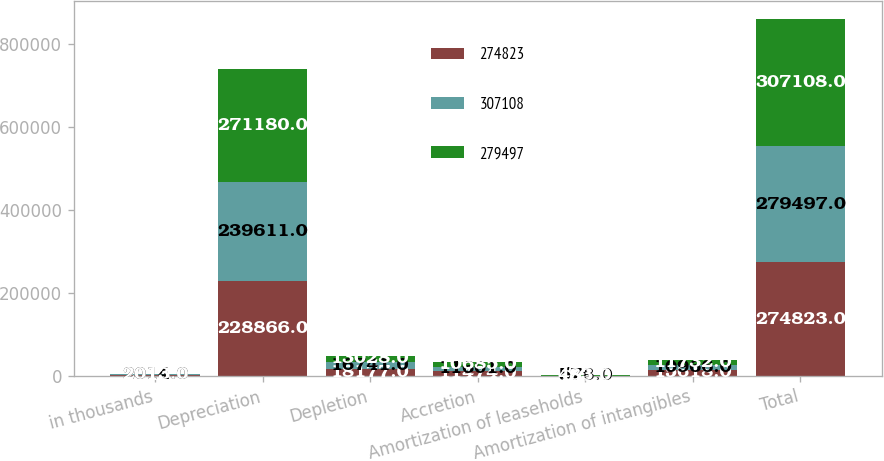Convert chart to OTSL. <chart><loc_0><loc_0><loc_500><loc_500><stacked_bar_chart><ecel><fcel>in thousands<fcel>Depreciation<fcel>Depletion<fcel>Accretion<fcel>Amortization of leaseholds<fcel>Amortization of intangibles<fcel>Total<nl><fcel>274823<fcel>2015<fcel>228866<fcel>18177<fcel>11474<fcel>688<fcel>15618<fcel>274823<nl><fcel>307108<fcel>2014<fcel>239611<fcel>16741<fcel>11601<fcel>578<fcel>10966<fcel>279497<nl><fcel>279497<fcel>2013<fcel>271180<fcel>13028<fcel>10685<fcel>483<fcel>11732<fcel>307108<nl></chart> 